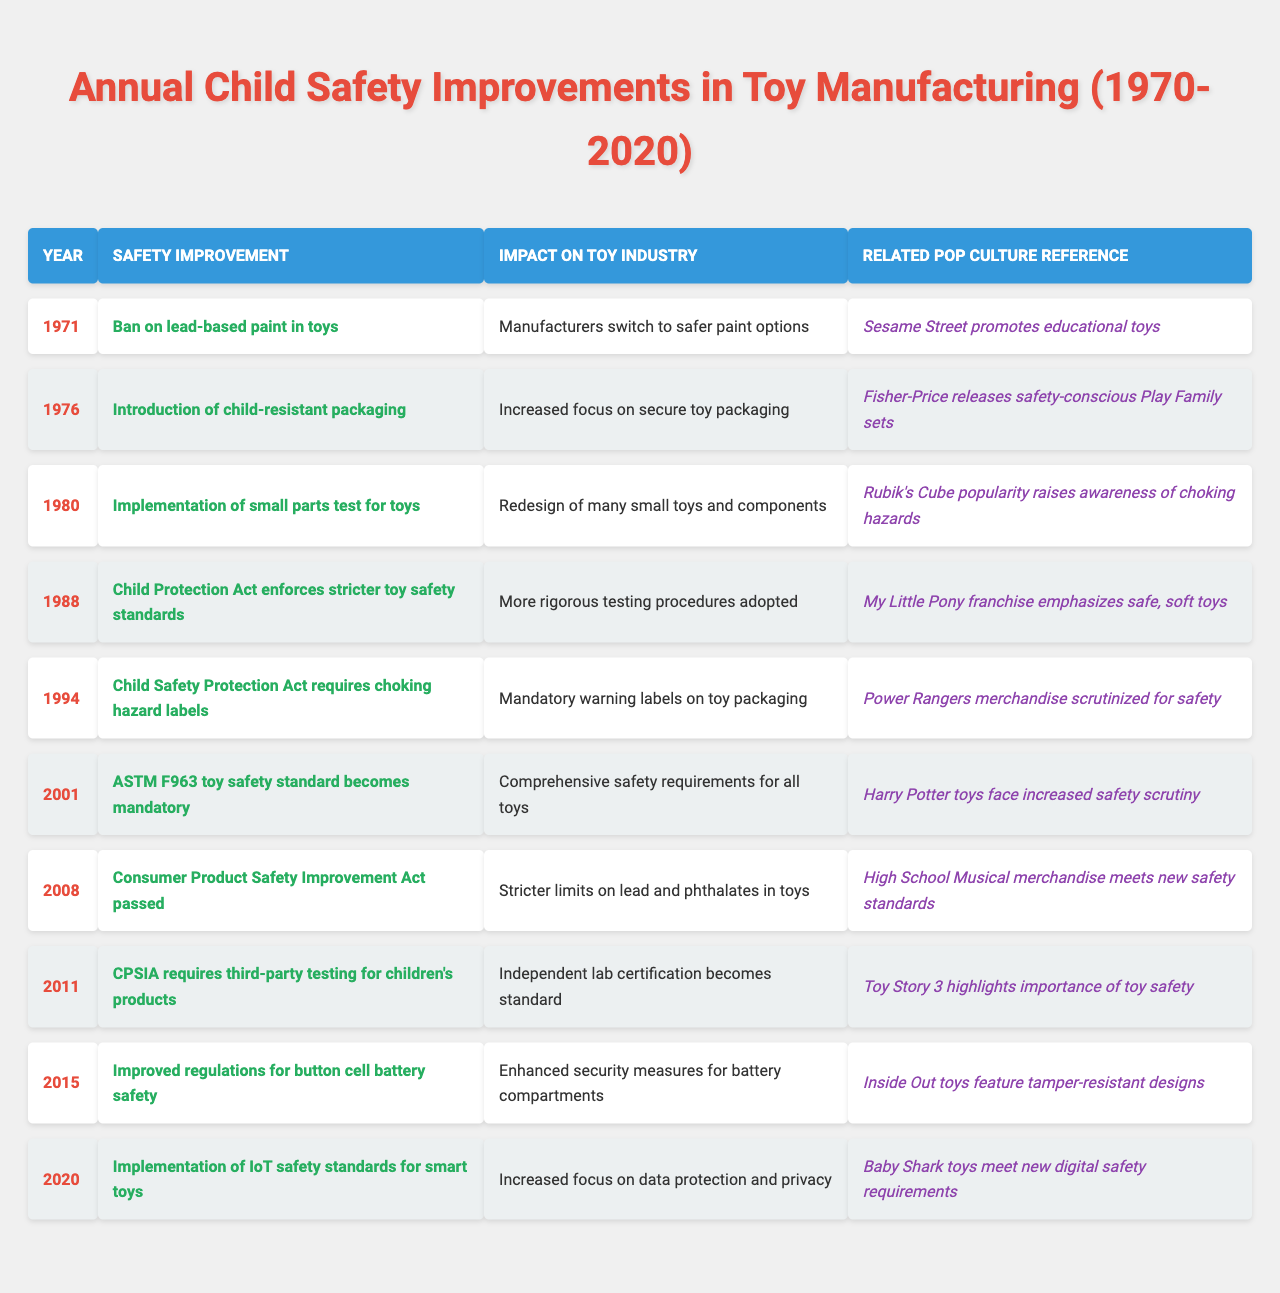What safety improvement was introduced in 1976? According to the table, the safety improvement introduced in 1976 was "Introduction of child-resistant packaging."
Answer: Child-resistant packaging What was the impact of the Child Protection Act in 1988? The Child Protection Act in 1988 led to more rigorous testing procedures being adopted in the toy industry.
Answer: More rigorous testing procedures How many significant safety improvements were implemented from 1970 to 2020? By counting the entries in the table from 1971 to 2020, there are 10 significant safety improvements listed.
Answer: 10 What pop culture reference is associated with toy safety improvements in 2001? The pop culture reference associated with toy safety improvements in 2001 is "Harry Potter toys face increased safety scrutiny."
Answer: Harry Potter toys scrutiny Was the implementation of the small parts test for toys introduced before or after 1980? It was introduced in 1980, so it was implemented in that year, not before or after.
Answer: In 1980 Which year saw the introduction of choking hazard labels, and what was its impact? Choking hazard labels were introduced in 1994, which required mandatory warning labels on toy packaging.
Answer: 1994, mandatory warning labels Considering the improvements, which year had the focus on digital safety requirements for smart toys? The year 2020 had the focus on digital safety with the implementation of IoT safety standards for smart toys.
Answer: 2020 What was the main focus of toy safety in 2008 based on the table? The main focus of toy safety in 2008 was on stricter limits on lead and phthalates in toys due to the Consumer Product Safety Improvement Act.
Answer: Stricter limits on lead and phthalates Which improvement took place most recently? The most recent improvement listed is the implementation of IoT safety standards for smart toys in 2020.
Answer: 2020 In what way did the introduction of ASTM F963 in 2001 influence the toy industry? The introduction of ASTM F963 in 2001 influenced the toy industry by creating comprehensive safety requirements for all toys.
Answer: Comprehensive safety requirements How did safety improvements from 1970 to 2020 evolve in terms of regulatory focus? Over the years, safety improvements evolved from basic material safety to encompassing comprehensive regulations including digital safety, reflecting a broader awareness of various safety concerns.
Answer: Evolved to include digital safety 